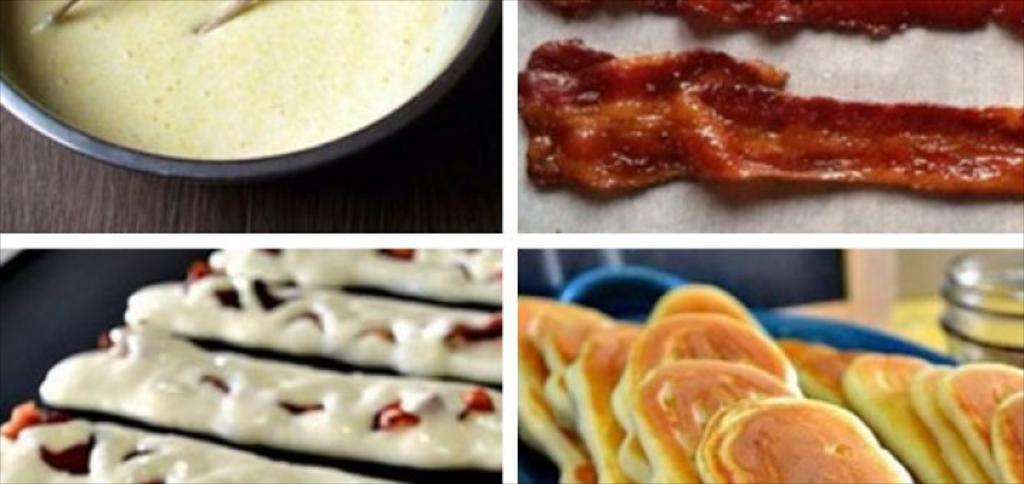What type of artwork is depicted in the image? The image is a collage. What kind of items are included in the collage? The collage contains images of eatable things. What type of attraction can be seen in the image? There is no attraction present in the image; it is a collage of eatable things. Can you provide a guide on how to play with the balls in the image? There are no balls present in the image, so a guide on how to play with them cannot be provided. 